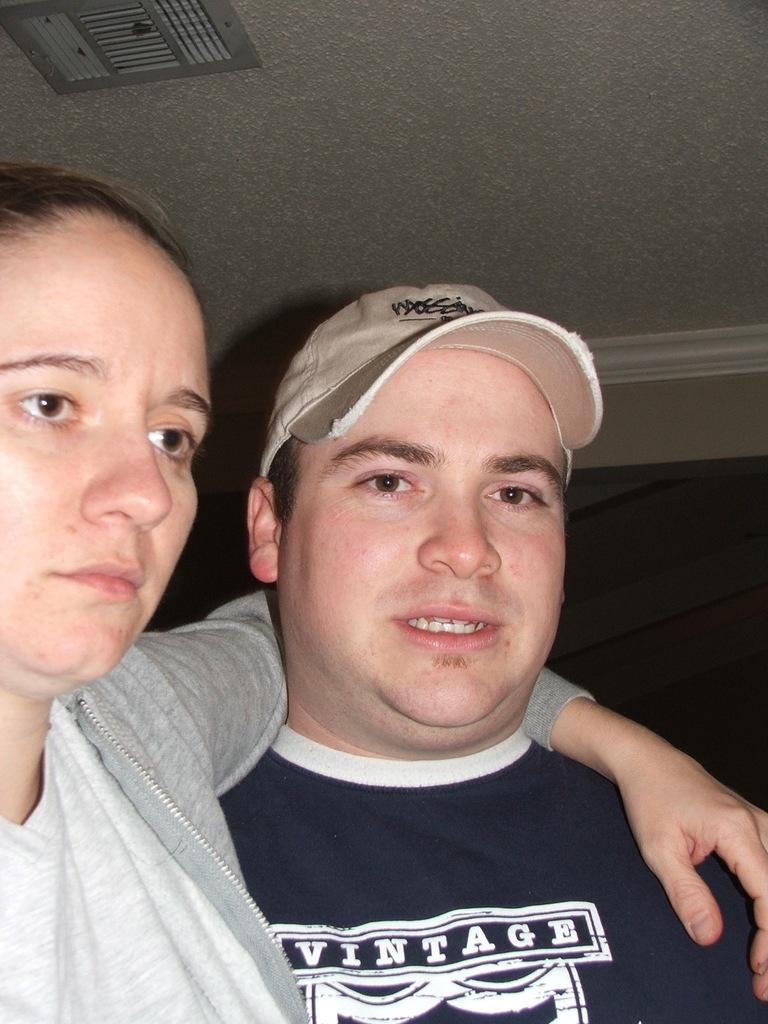<image>
Summarize the visual content of the image. woman with her arm around man wearing blue vintage shirt 